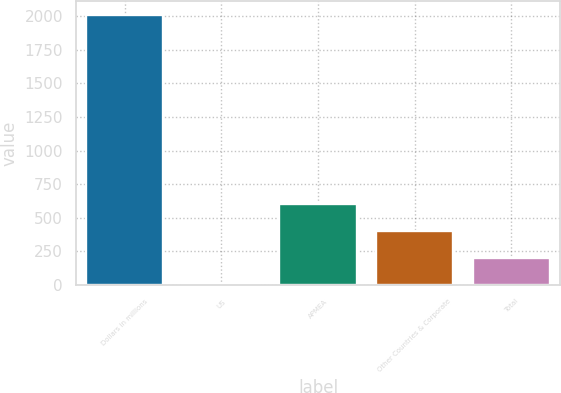Convert chart to OTSL. <chart><loc_0><loc_0><loc_500><loc_500><bar_chart><fcel>Dollars in millions<fcel>US<fcel>APMEA<fcel>Other Countries & Corporate<fcel>Total<nl><fcel>2009<fcel>1<fcel>603.4<fcel>402.6<fcel>201.8<nl></chart> 